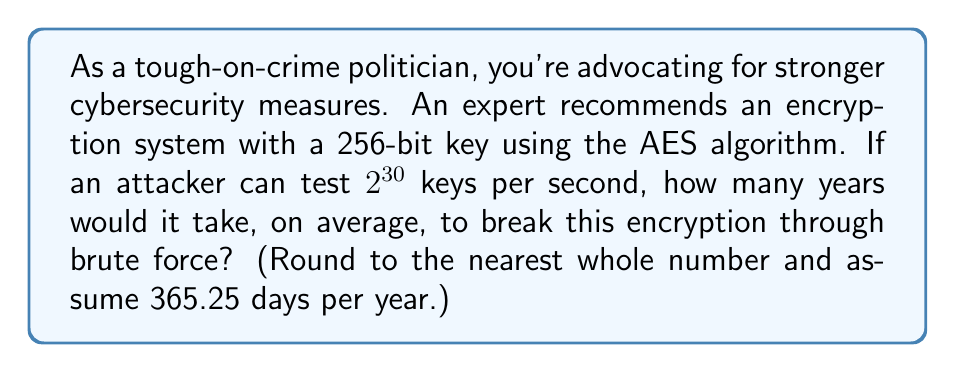Show me your answer to this math problem. Let's approach this step-by-step:

1) The total number of possible keys in a 256-bit system is $2^{256}$.

2) On average, an attacker would need to try half of all possible keys before finding the correct one. So, the expected number of keys to try is:

   $$\frac{2^{256}}{2} = 2^{255}$$

3) The attacker can test $2^{30}$ keys per second. To find the number of seconds needed, we divide the number of keys to try by the testing rate:

   $$\frac{2^{255}}{2^{30}} = 2^{225} \text{ seconds}$$

4) To convert this to years, we need to divide by the number of seconds in a year:
   
   Seconds in a year = 365.25 days × 24 hours × 60 minutes × 60 seconds = 31,557,600

5) Years needed:

   $$\frac{2^{225}}{31,557,600} = \frac{2^{225}}{2^{24.91}} \approx 2^{200.09} \text{ years}$$

6) Calculate this value:

   $$2^{200.09} \approx 1.6325 \times 10^{60} \text{ years}$$

7) Rounding to the nearest whole number:

   $$1.6325 \times 10^{60} \approx 2 \times 10^{60} \text{ years}$$
Answer: $2 \times 10^{60}$ years 